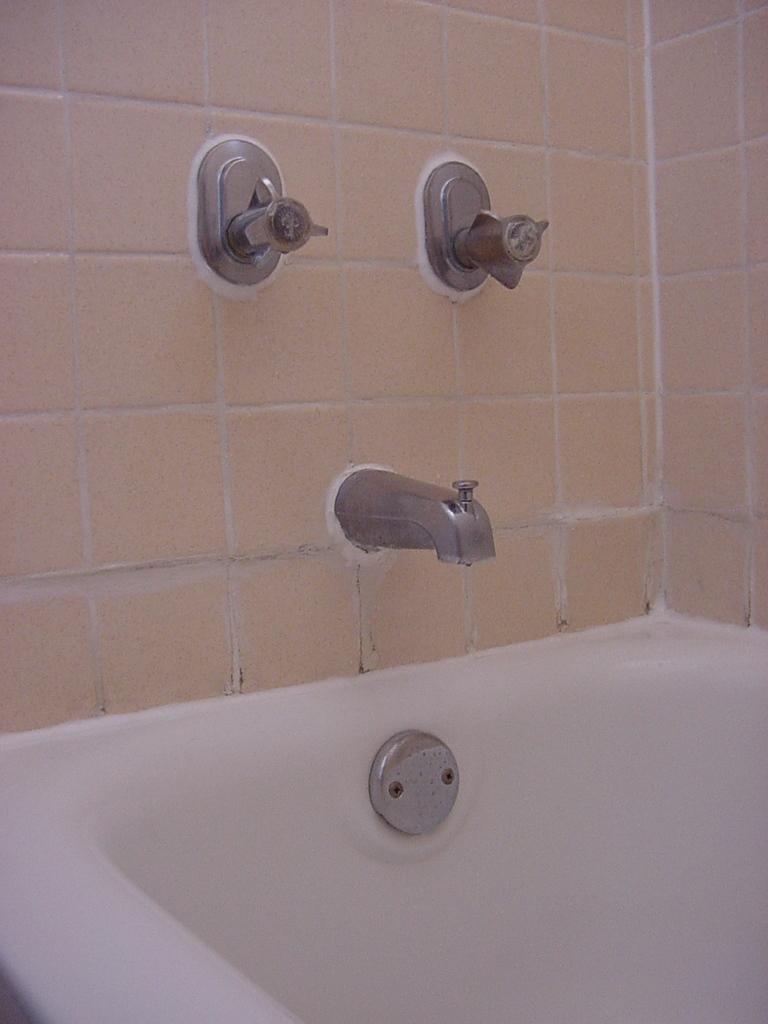What is the main object in the image? There is a bathtub in the image. What is located in the center of the image? There are tapes in the center of the image. What type of material covers the walls in the image? The walls have tiles in the image. How many brothers are sitting on the chairs in the image? There are no chairs or brothers present in the image. Can you describe the kiss between the two individuals in the image? There are no individuals or kisses depicted in the image. 